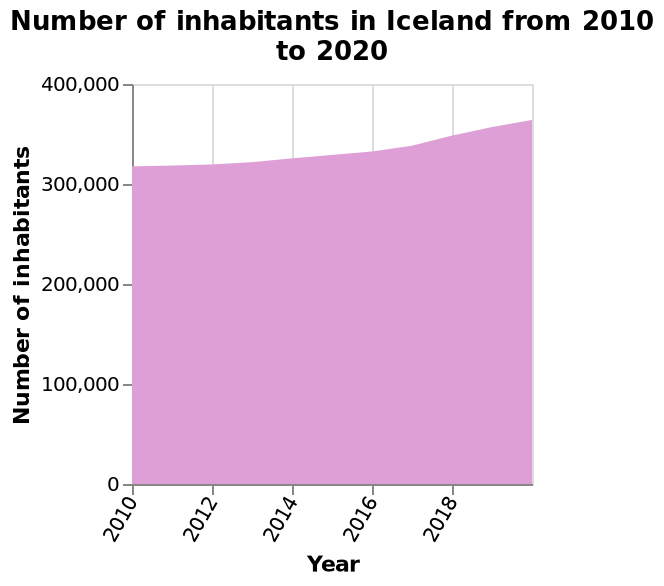<image>
What is the current estimated population of Iceland as of 2020?  As of 2020, the population of Iceland has not yet reached 400,000. Offer a thorough analysis of the image. The number of inhabitants of Iceland has increased by less than 100,000 between 2010-2020. The number of inhabitants of Iceland has not yet reached 400,000 as of 2020. What is being represented on the y-axis? The year. What is the time period covered by the area diagram? The time period is from 2010 to 2020. What does the area diagram represent for Iceland? The population trend of Iceland over the years. 